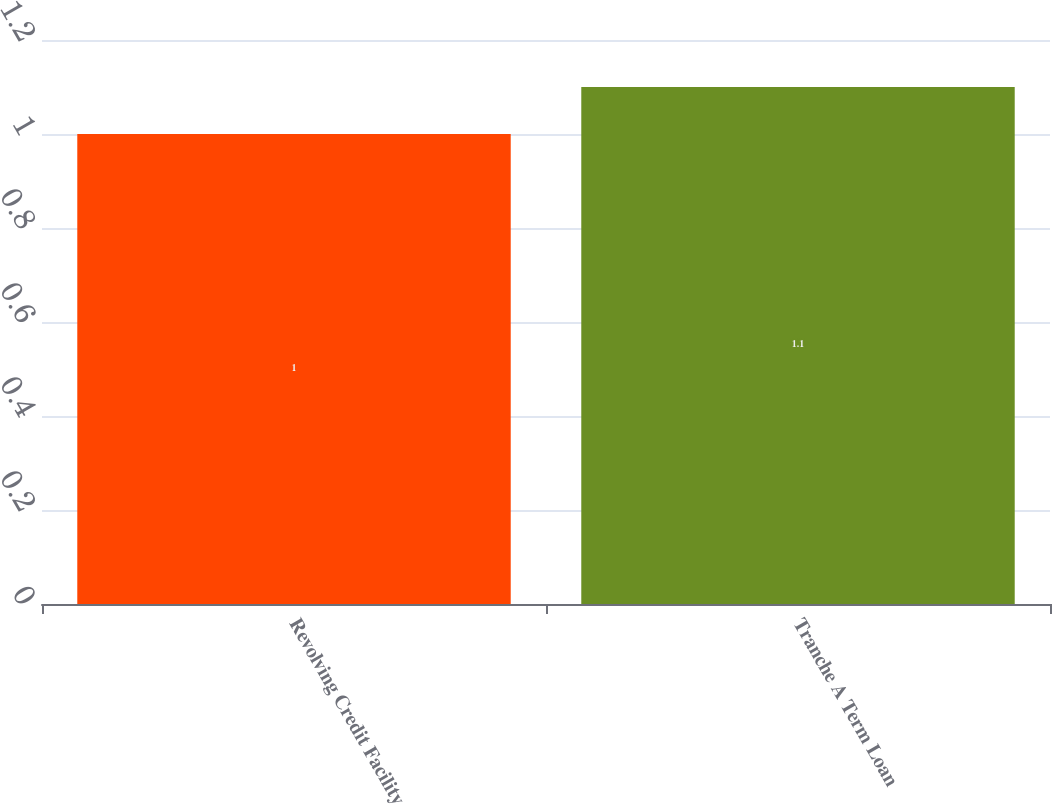Convert chart. <chart><loc_0><loc_0><loc_500><loc_500><bar_chart><fcel>Revolving Credit Facility<fcel>Tranche A Term Loan<nl><fcel>1<fcel>1.1<nl></chart> 